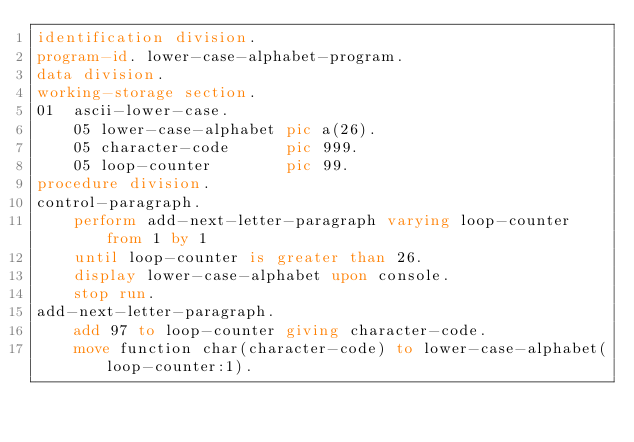Convert code to text. <code><loc_0><loc_0><loc_500><loc_500><_COBOL_>identification division.
program-id. lower-case-alphabet-program.
data division.
working-storage section.
01  ascii-lower-case.
    05 lower-case-alphabet pic a(26).
    05 character-code      pic 999.
    05 loop-counter        pic 99.
procedure division.
control-paragraph.
    perform add-next-letter-paragraph varying loop-counter from 1 by 1
    until loop-counter is greater than 26.
    display lower-case-alphabet upon console.
    stop run.
add-next-letter-paragraph.
    add 97 to loop-counter giving character-code.
    move function char(character-code) to lower-case-alphabet(loop-counter:1).
</code> 